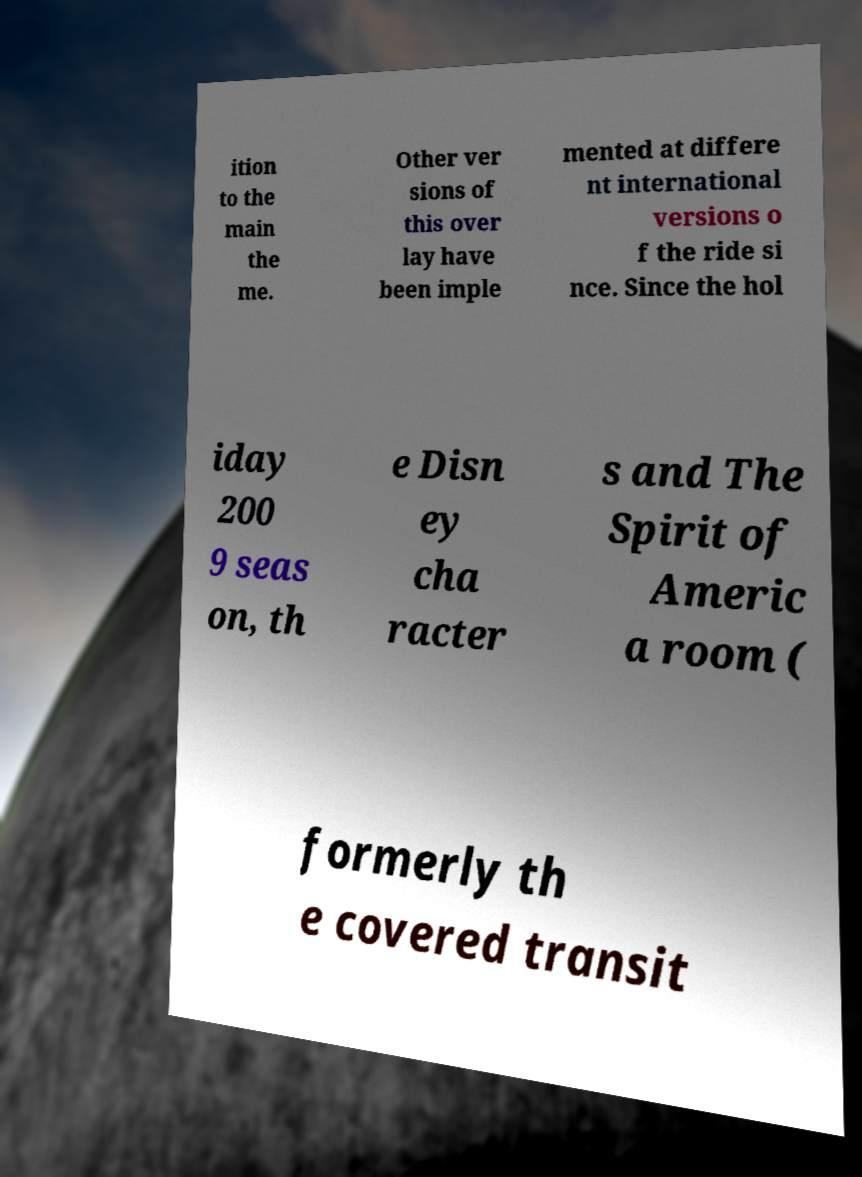Could you assist in decoding the text presented in this image and type it out clearly? ition to the main the me. Other ver sions of this over lay have been imple mented at differe nt international versions o f the ride si nce. Since the hol iday 200 9 seas on, th e Disn ey cha racter s and The Spirit of Americ a room ( formerly th e covered transit 